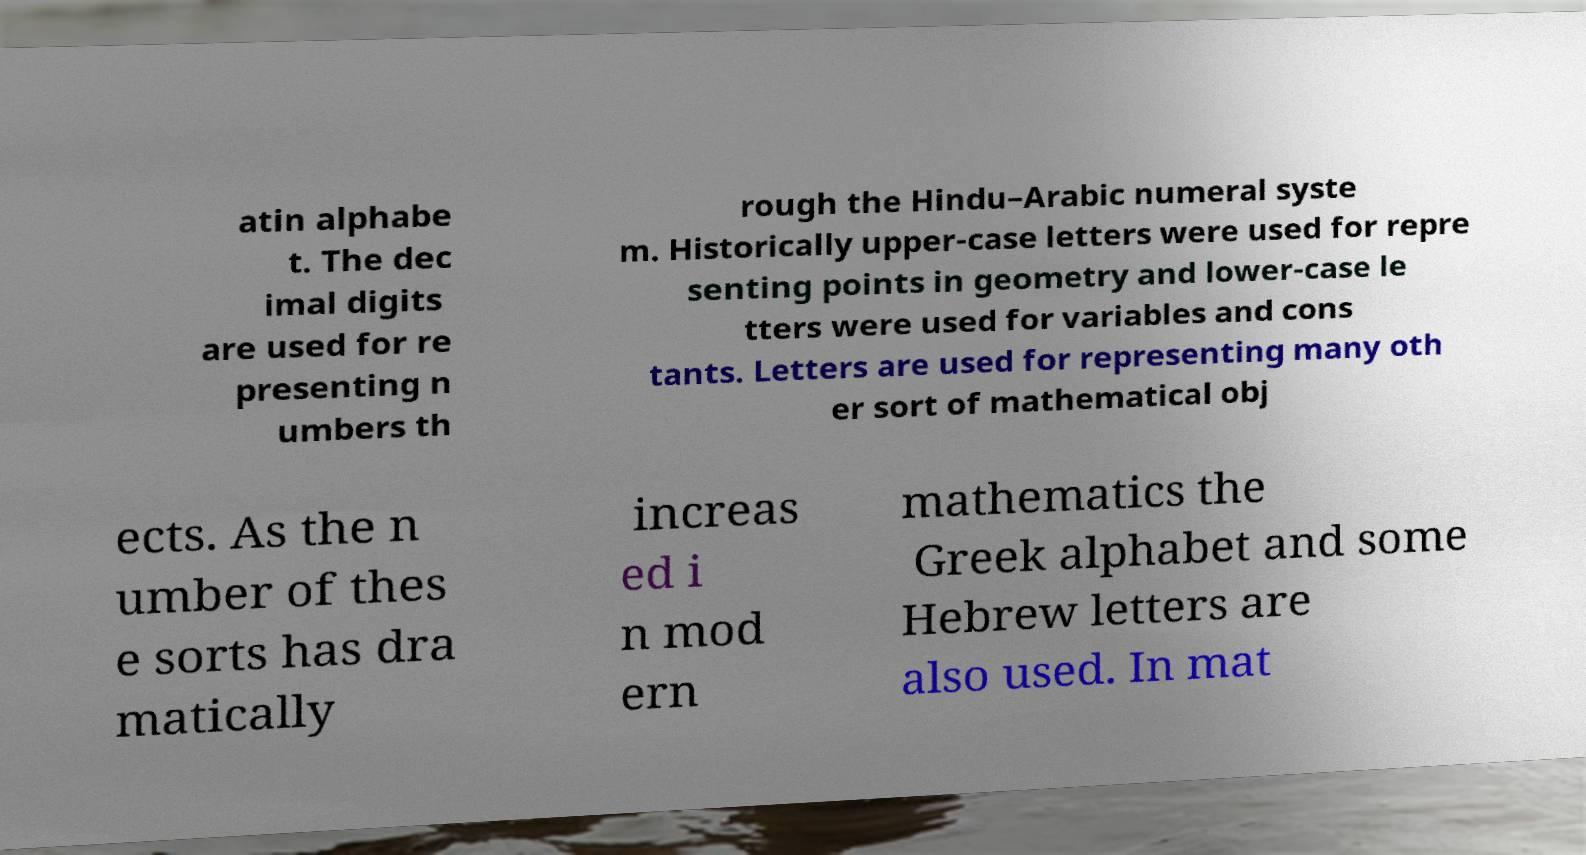I need the written content from this picture converted into text. Can you do that? atin alphabe t. The dec imal digits are used for re presenting n umbers th rough the Hindu–Arabic numeral syste m. Historically upper-case letters were used for repre senting points in geometry and lower-case le tters were used for variables and cons tants. Letters are used for representing many oth er sort of mathematical obj ects. As the n umber of thes e sorts has dra matically increas ed i n mod ern mathematics the Greek alphabet and some Hebrew letters are also used. In mat 